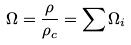<formula> <loc_0><loc_0><loc_500><loc_500>\Omega = \frac { \rho } { \rho _ { c } } = \sum \Omega _ { i }</formula> 